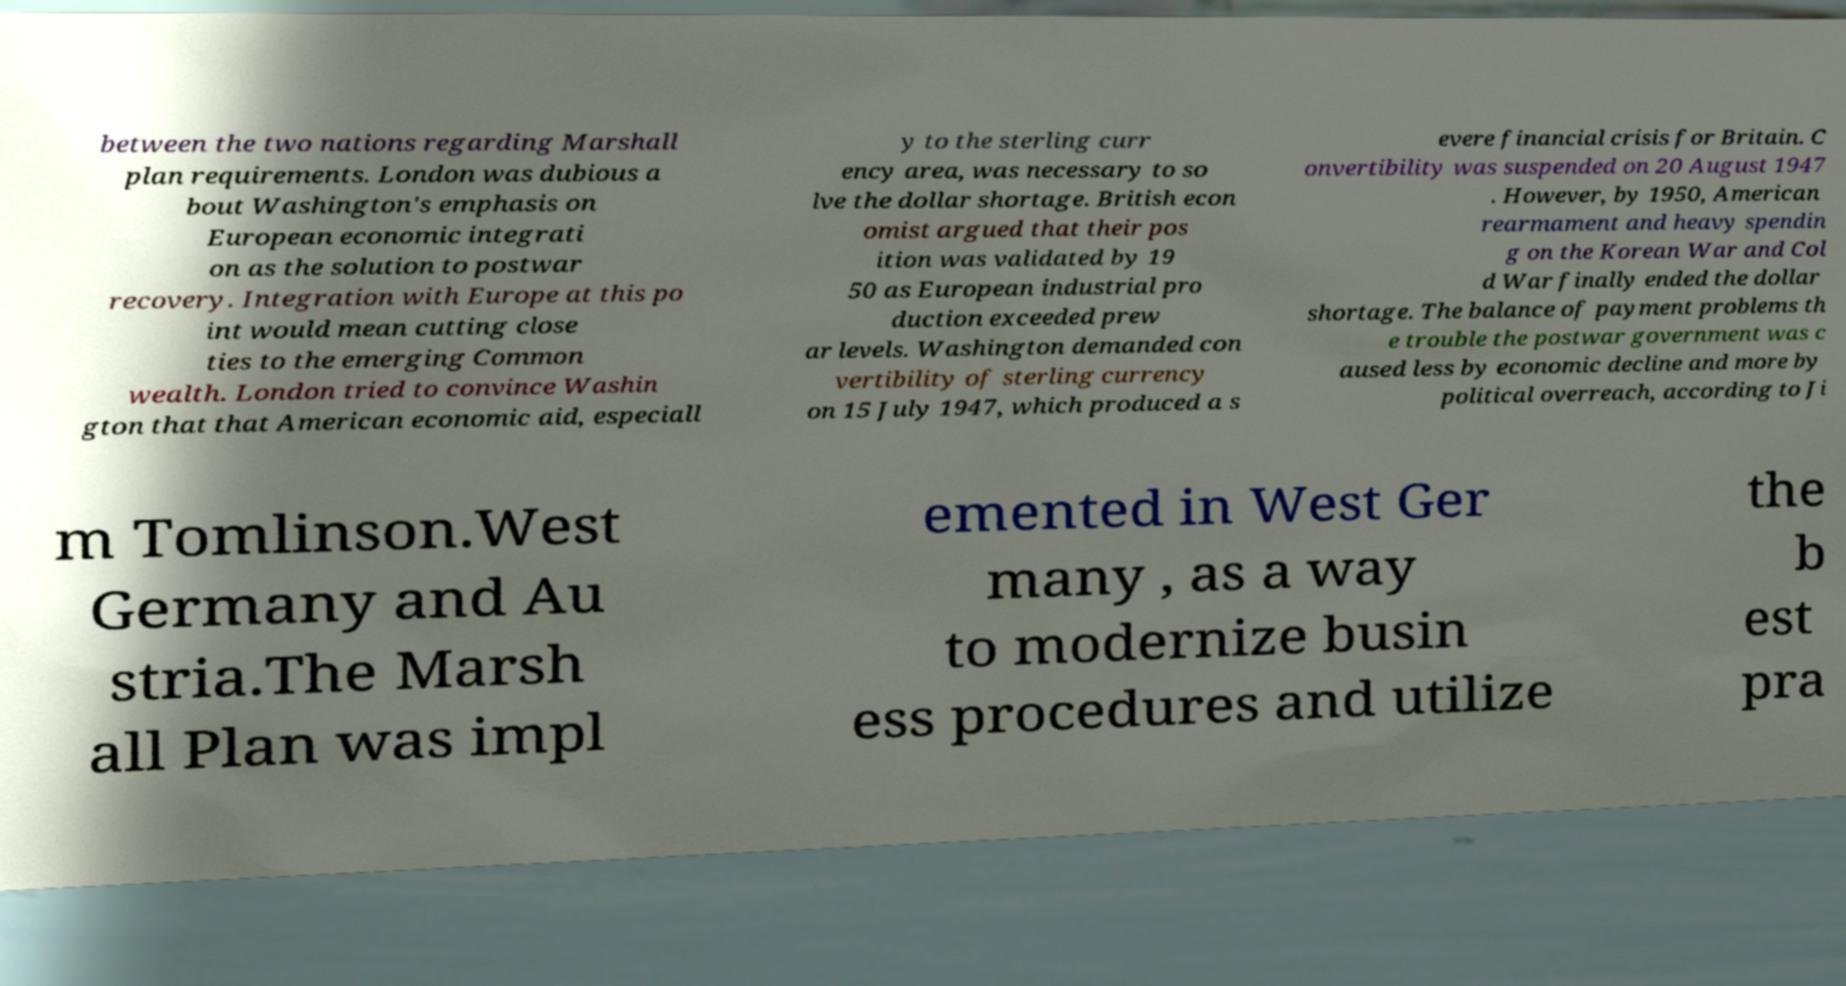What messages or text are displayed in this image? I need them in a readable, typed format. between the two nations regarding Marshall plan requirements. London was dubious a bout Washington's emphasis on European economic integrati on as the solution to postwar recovery. Integration with Europe at this po int would mean cutting close ties to the emerging Common wealth. London tried to convince Washin gton that that American economic aid, especiall y to the sterling curr ency area, was necessary to so lve the dollar shortage. British econ omist argued that their pos ition was validated by 19 50 as European industrial pro duction exceeded prew ar levels. Washington demanded con vertibility of sterling currency on 15 July 1947, which produced a s evere financial crisis for Britain. C onvertibility was suspended on 20 August 1947 . However, by 1950, American rearmament and heavy spendin g on the Korean War and Col d War finally ended the dollar shortage. The balance of payment problems th e trouble the postwar government was c aused less by economic decline and more by political overreach, according to Ji m Tomlinson.West Germany and Au stria.The Marsh all Plan was impl emented in West Ger many , as a way to modernize busin ess procedures and utilize the b est pra 